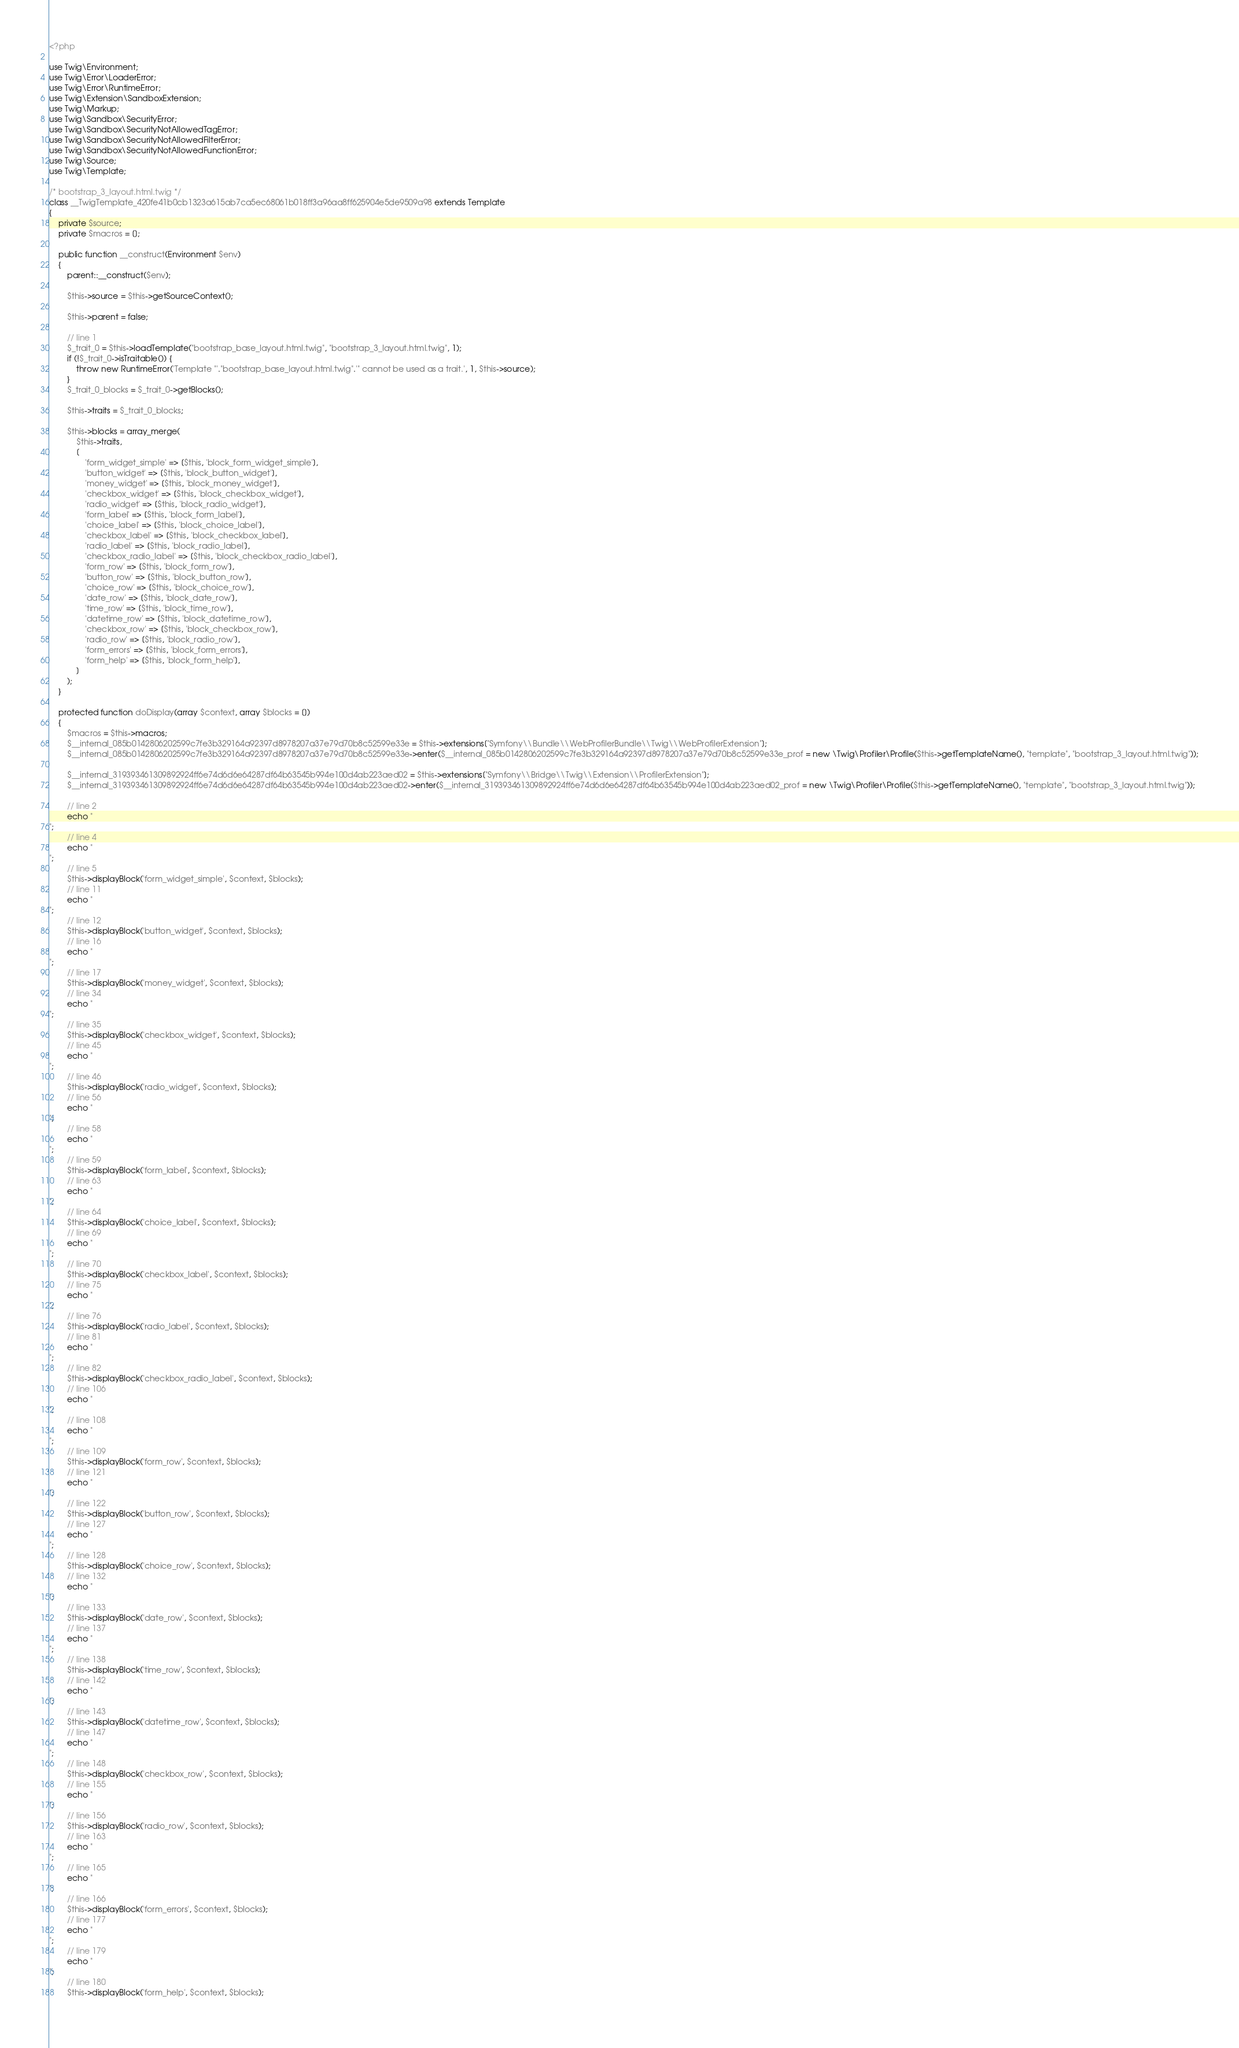Convert code to text. <code><loc_0><loc_0><loc_500><loc_500><_PHP_><?php

use Twig\Environment;
use Twig\Error\LoaderError;
use Twig\Error\RuntimeError;
use Twig\Extension\SandboxExtension;
use Twig\Markup;
use Twig\Sandbox\SecurityError;
use Twig\Sandbox\SecurityNotAllowedTagError;
use Twig\Sandbox\SecurityNotAllowedFilterError;
use Twig\Sandbox\SecurityNotAllowedFunctionError;
use Twig\Source;
use Twig\Template;

/* bootstrap_3_layout.html.twig */
class __TwigTemplate_420fe41b0cb1323a615ab7ca5ec68061b018ff3a96aa8ff625904e5de9509a98 extends Template
{
    private $source;
    private $macros = [];

    public function __construct(Environment $env)
    {
        parent::__construct($env);

        $this->source = $this->getSourceContext();

        $this->parent = false;

        // line 1
        $_trait_0 = $this->loadTemplate("bootstrap_base_layout.html.twig", "bootstrap_3_layout.html.twig", 1);
        if (!$_trait_0->isTraitable()) {
            throw new RuntimeError('Template "'."bootstrap_base_layout.html.twig".'" cannot be used as a trait.', 1, $this->source);
        }
        $_trait_0_blocks = $_trait_0->getBlocks();

        $this->traits = $_trait_0_blocks;

        $this->blocks = array_merge(
            $this->traits,
            [
                'form_widget_simple' => [$this, 'block_form_widget_simple'],
                'button_widget' => [$this, 'block_button_widget'],
                'money_widget' => [$this, 'block_money_widget'],
                'checkbox_widget' => [$this, 'block_checkbox_widget'],
                'radio_widget' => [$this, 'block_radio_widget'],
                'form_label' => [$this, 'block_form_label'],
                'choice_label' => [$this, 'block_choice_label'],
                'checkbox_label' => [$this, 'block_checkbox_label'],
                'radio_label' => [$this, 'block_radio_label'],
                'checkbox_radio_label' => [$this, 'block_checkbox_radio_label'],
                'form_row' => [$this, 'block_form_row'],
                'button_row' => [$this, 'block_button_row'],
                'choice_row' => [$this, 'block_choice_row'],
                'date_row' => [$this, 'block_date_row'],
                'time_row' => [$this, 'block_time_row'],
                'datetime_row' => [$this, 'block_datetime_row'],
                'checkbox_row' => [$this, 'block_checkbox_row'],
                'radio_row' => [$this, 'block_radio_row'],
                'form_errors' => [$this, 'block_form_errors'],
                'form_help' => [$this, 'block_form_help'],
            ]
        );
    }

    protected function doDisplay(array $context, array $blocks = [])
    {
        $macros = $this->macros;
        $__internal_085b0142806202599c7fe3b329164a92397d8978207a37e79d70b8c52599e33e = $this->extensions["Symfony\\Bundle\\WebProfilerBundle\\Twig\\WebProfilerExtension"];
        $__internal_085b0142806202599c7fe3b329164a92397d8978207a37e79d70b8c52599e33e->enter($__internal_085b0142806202599c7fe3b329164a92397d8978207a37e79d70b8c52599e33e_prof = new \Twig\Profiler\Profile($this->getTemplateName(), "template", "bootstrap_3_layout.html.twig"));

        $__internal_319393461309892924ff6e74d6d6e64287df64b63545b994e100d4ab223aed02 = $this->extensions["Symfony\\Bridge\\Twig\\Extension\\ProfilerExtension"];
        $__internal_319393461309892924ff6e74d6d6e64287df64b63545b994e100d4ab223aed02->enter($__internal_319393461309892924ff6e74d6d6e64287df64b63545b994e100d4ab223aed02_prof = new \Twig\Profiler\Profile($this->getTemplateName(), "template", "bootstrap_3_layout.html.twig"));

        // line 2
        echo "
";
        // line 4
        echo "
";
        // line 5
        $this->displayBlock('form_widget_simple', $context, $blocks);
        // line 11
        echo "
";
        // line 12
        $this->displayBlock('button_widget', $context, $blocks);
        // line 16
        echo "
";
        // line 17
        $this->displayBlock('money_widget', $context, $blocks);
        // line 34
        echo "
";
        // line 35
        $this->displayBlock('checkbox_widget', $context, $blocks);
        // line 45
        echo "
";
        // line 46
        $this->displayBlock('radio_widget', $context, $blocks);
        // line 56
        echo "
";
        // line 58
        echo "
";
        // line 59
        $this->displayBlock('form_label', $context, $blocks);
        // line 63
        echo "
";
        // line 64
        $this->displayBlock('choice_label', $context, $blocks);
        // line 69
        echo "
";
        // line 70
        $this->displayBlock('checkbox_label', $context, $blocks);
        // line 75
        echo "
";
        // line 76
        $this->displayBlock('radio_label', $context, $blocks);
        // line 81
        echo "
";
        // line 82
        $this->displayBlock('checkbox_radio_label', $context, $blocks);
        // line 106
        echo "
";
        // line 108
        echo "
";
        // line 109
        $this->displayBlock('form_row', $context, $blocks);
        // line 121
        echo "
";
        // line 122
        $this->displayBlock('button_row', $context, $blocks);
        // line 127
        echo "
";
        // line 128
        $this->displayBlock('choice_row', $context, $blocks);
        // line 132
        echo "
";
        // line 133
        $this->displayBlock('date_row', $context, $blocks);
        // line 137
        echo "
";
        // line 138
        $this->displayBlock('time_row', $context, $blocks);
        // line 142
        echo "
";
        // line 143
        $this->displayBlock('datetime_row', $context, $blocks);
        // line 147
        echo "
";
        // line 148
        $this->displayBlock('checkbox_row', $context, $blocks);
        // line 155
        echo "
";
        // line 156
        $this->displayBlock('radio_row', $context, $blocks);
        // line 163
        echo "
";
        // line 165
        echo "
";
        // line 166
        $this->displayBlock('form_errors', $context, $blocks);
        // line 177
        echo "
";
        // line 179
        echo "
";
        // line 180
        $this->displayBlock('form_help', $context, $blocks);
        </code> 